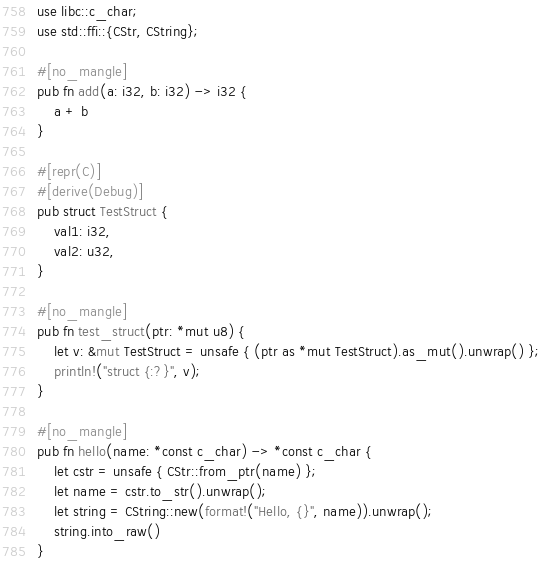Convert code to text. <code><loc_0><loc_0><loc_500><loc_500><_Rust_>use libc::c_char;
use std::ffi::{CStr, CString};

#[no_mangle]
pub fn add(a: i32, b: i32) -> i32 {
    a + b
}

#[repr(C)]
#[derive(Debug)]
pub struct TestStruct {
    val1: i32,
    val2: u32,
}

#[no_mangle]
pub fn test_struct(ptr: *mut u8) {
    let v: &mut TestStruct = unsafe { (ptr as *mut TestStruct).as_mut().unwrap() };
    println!("struct {:?}", v);
}

#[no_mangle]
pub fn hello(name: *const c_char) -> *const c_char {
    let cstr = unsafe { CStr::from_ptr(name) };
    let name = cstr.to_str().unwrap();
    let string = CString::new(format!("Hello, {}", name)).unwrap();
    string.into_raw()
}
</code> 